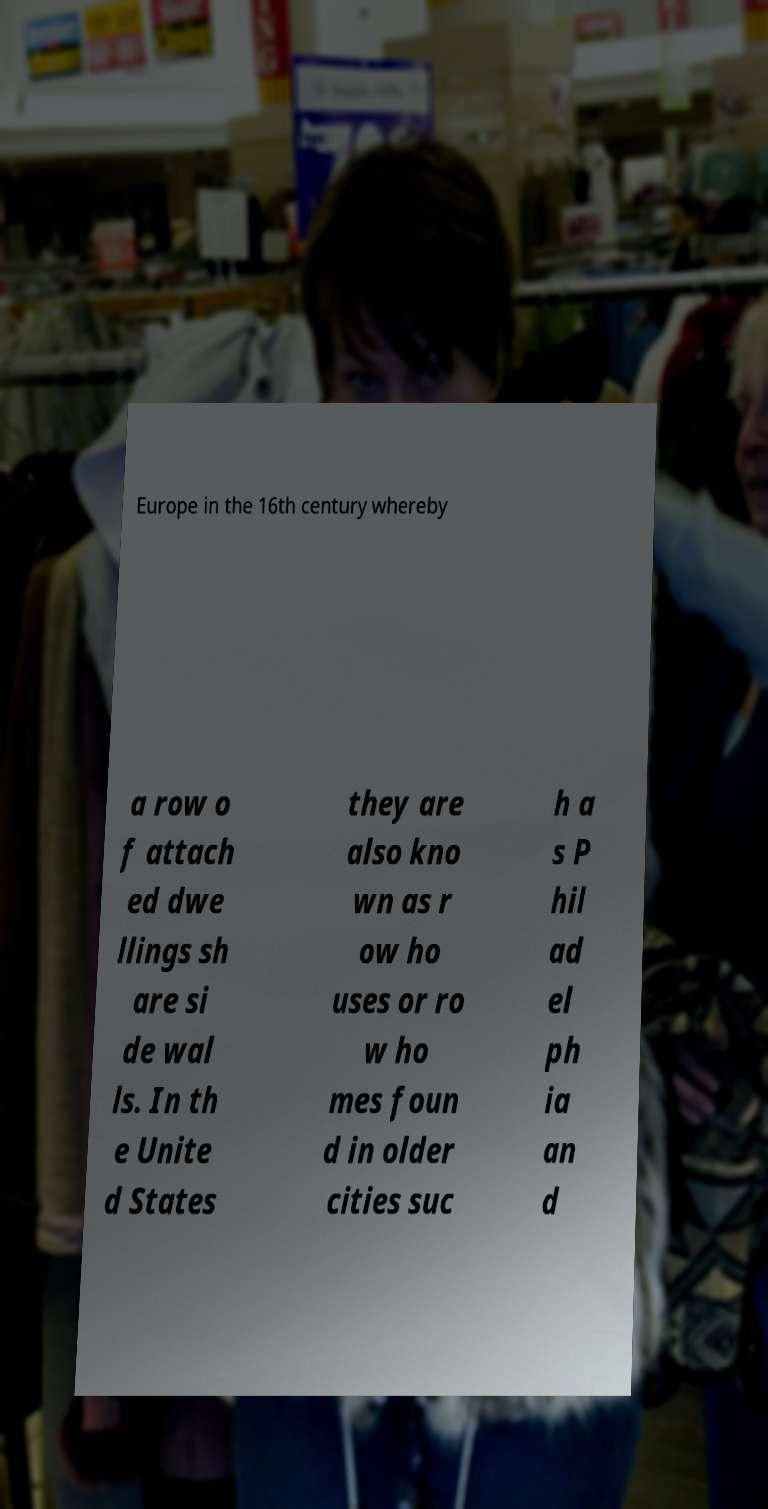Please identify and transcribe the text found in this image. Europe in the 16th century whereby a row o f attach ed dwe llings sh are si de wal ls. In th e Unite d States they are also kno wn as r ow ho uses or ro w ho mes foun d in older cities suc h a s P hil ad el ph ia an d 